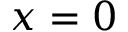Convert formula to latex. <formula><loc_0><loc_0><loc_500><loc_500>x = 0</formula> 